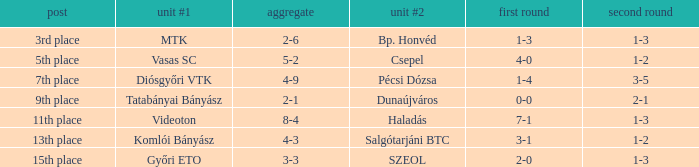Would you be able to parse every entry in this table? {'header': ['post', 'unit #1', 'aggregate', 'unit #2', 'first round', 'second round'], 'rows': [['3rd place', 'MTK', '2-6', 'Bp. Honvéd', '1-3', '1-3'], ['5th place', 'Vasas SC', '5-2', 'Csepel', '4-0', '1-2'], ['7th place', 'Diósgyőri VTK', '4-9', 'Pécsi Dózsa', '1-4', '3-5'], ['9th place', 'Tatabányai Bányász', '2-1', 'Dunaújváros', '0-0', '2-1'], ['11th place', 'Videoton', '8-4', 'Haladás', '7-1', '1-3'], ['13th place', 'Komlói Bányász', '4-3', 'Salgótarjáni BTC', '3-1', '1-2'], ['15th place', 'Győri ETO', '3-3', 'SZEOL', '2-0', '1-3']]} What is the 1st leg with a 4-3 agg.? 3-1. 